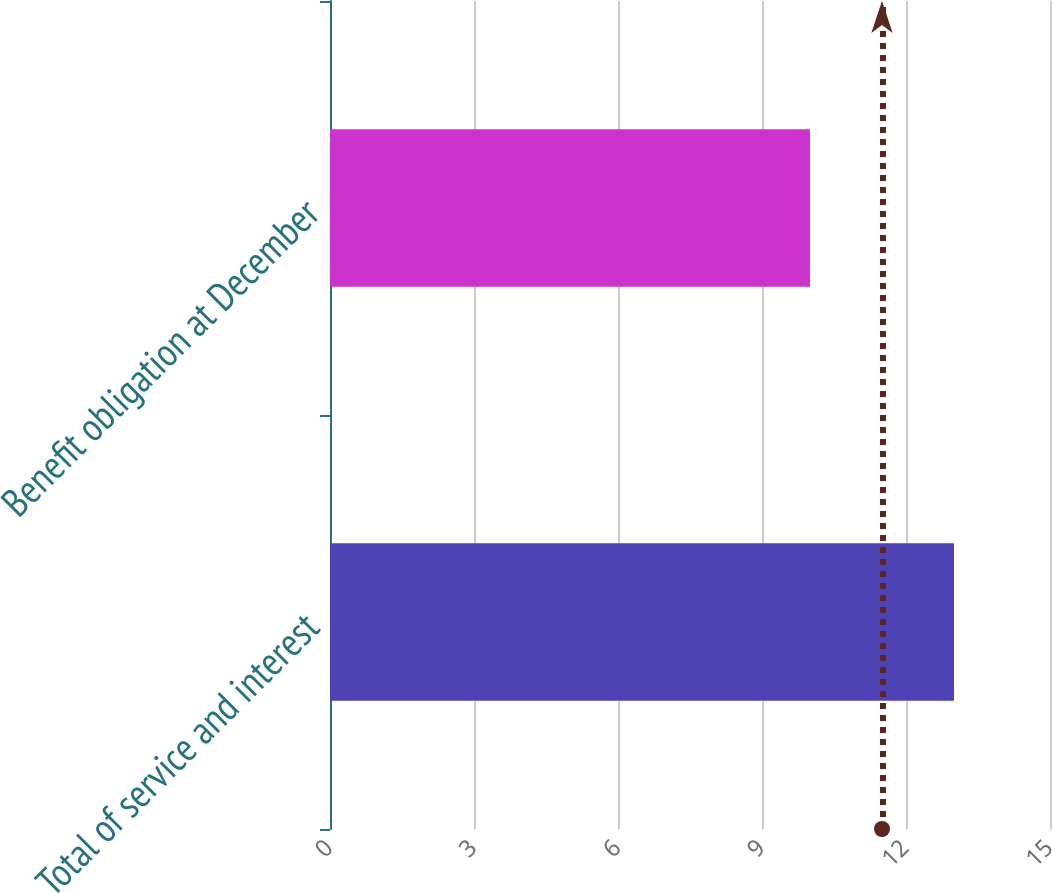<chart> <loc_0><loc_0><loc_500><loc_500><bar_chart><fcel>Total of service and interest<fcel>Benefit obligation at December<nl><fcel>13<fcel>10<nl></chart> 